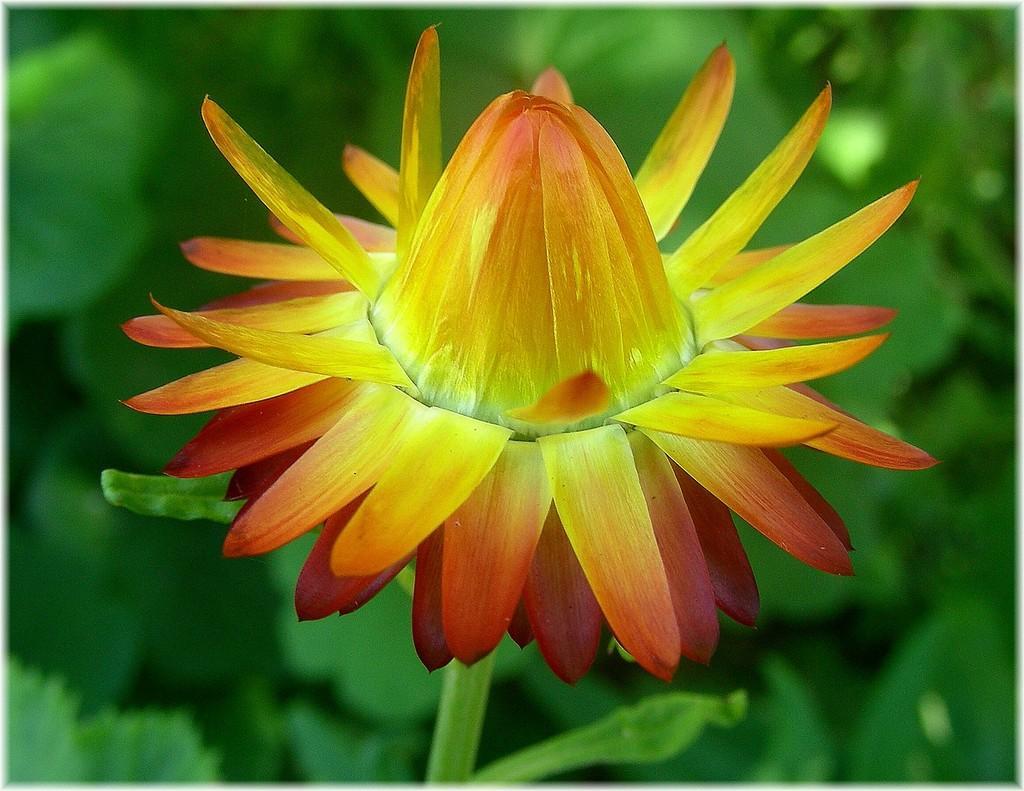How would you summarize this image in a sentence or two? In this picture we can see the flowers painting. In the back we can see some plants and leaves. 